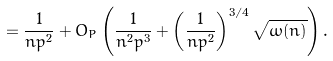<formula> <loc_0><loc_0><loc_500><loc_500>= \frac { 1 } { n p ^ { 2 } } + O _ { P } \left ( \frac { 1 } { n ^ { 2 } p ^ { 3 } } + \left ( \frac { 1 } { n p ^ { 2 } } \right ) ^ { 3 / 4 } \sqrt { \omega ( n ) } \right ) .</formula> 